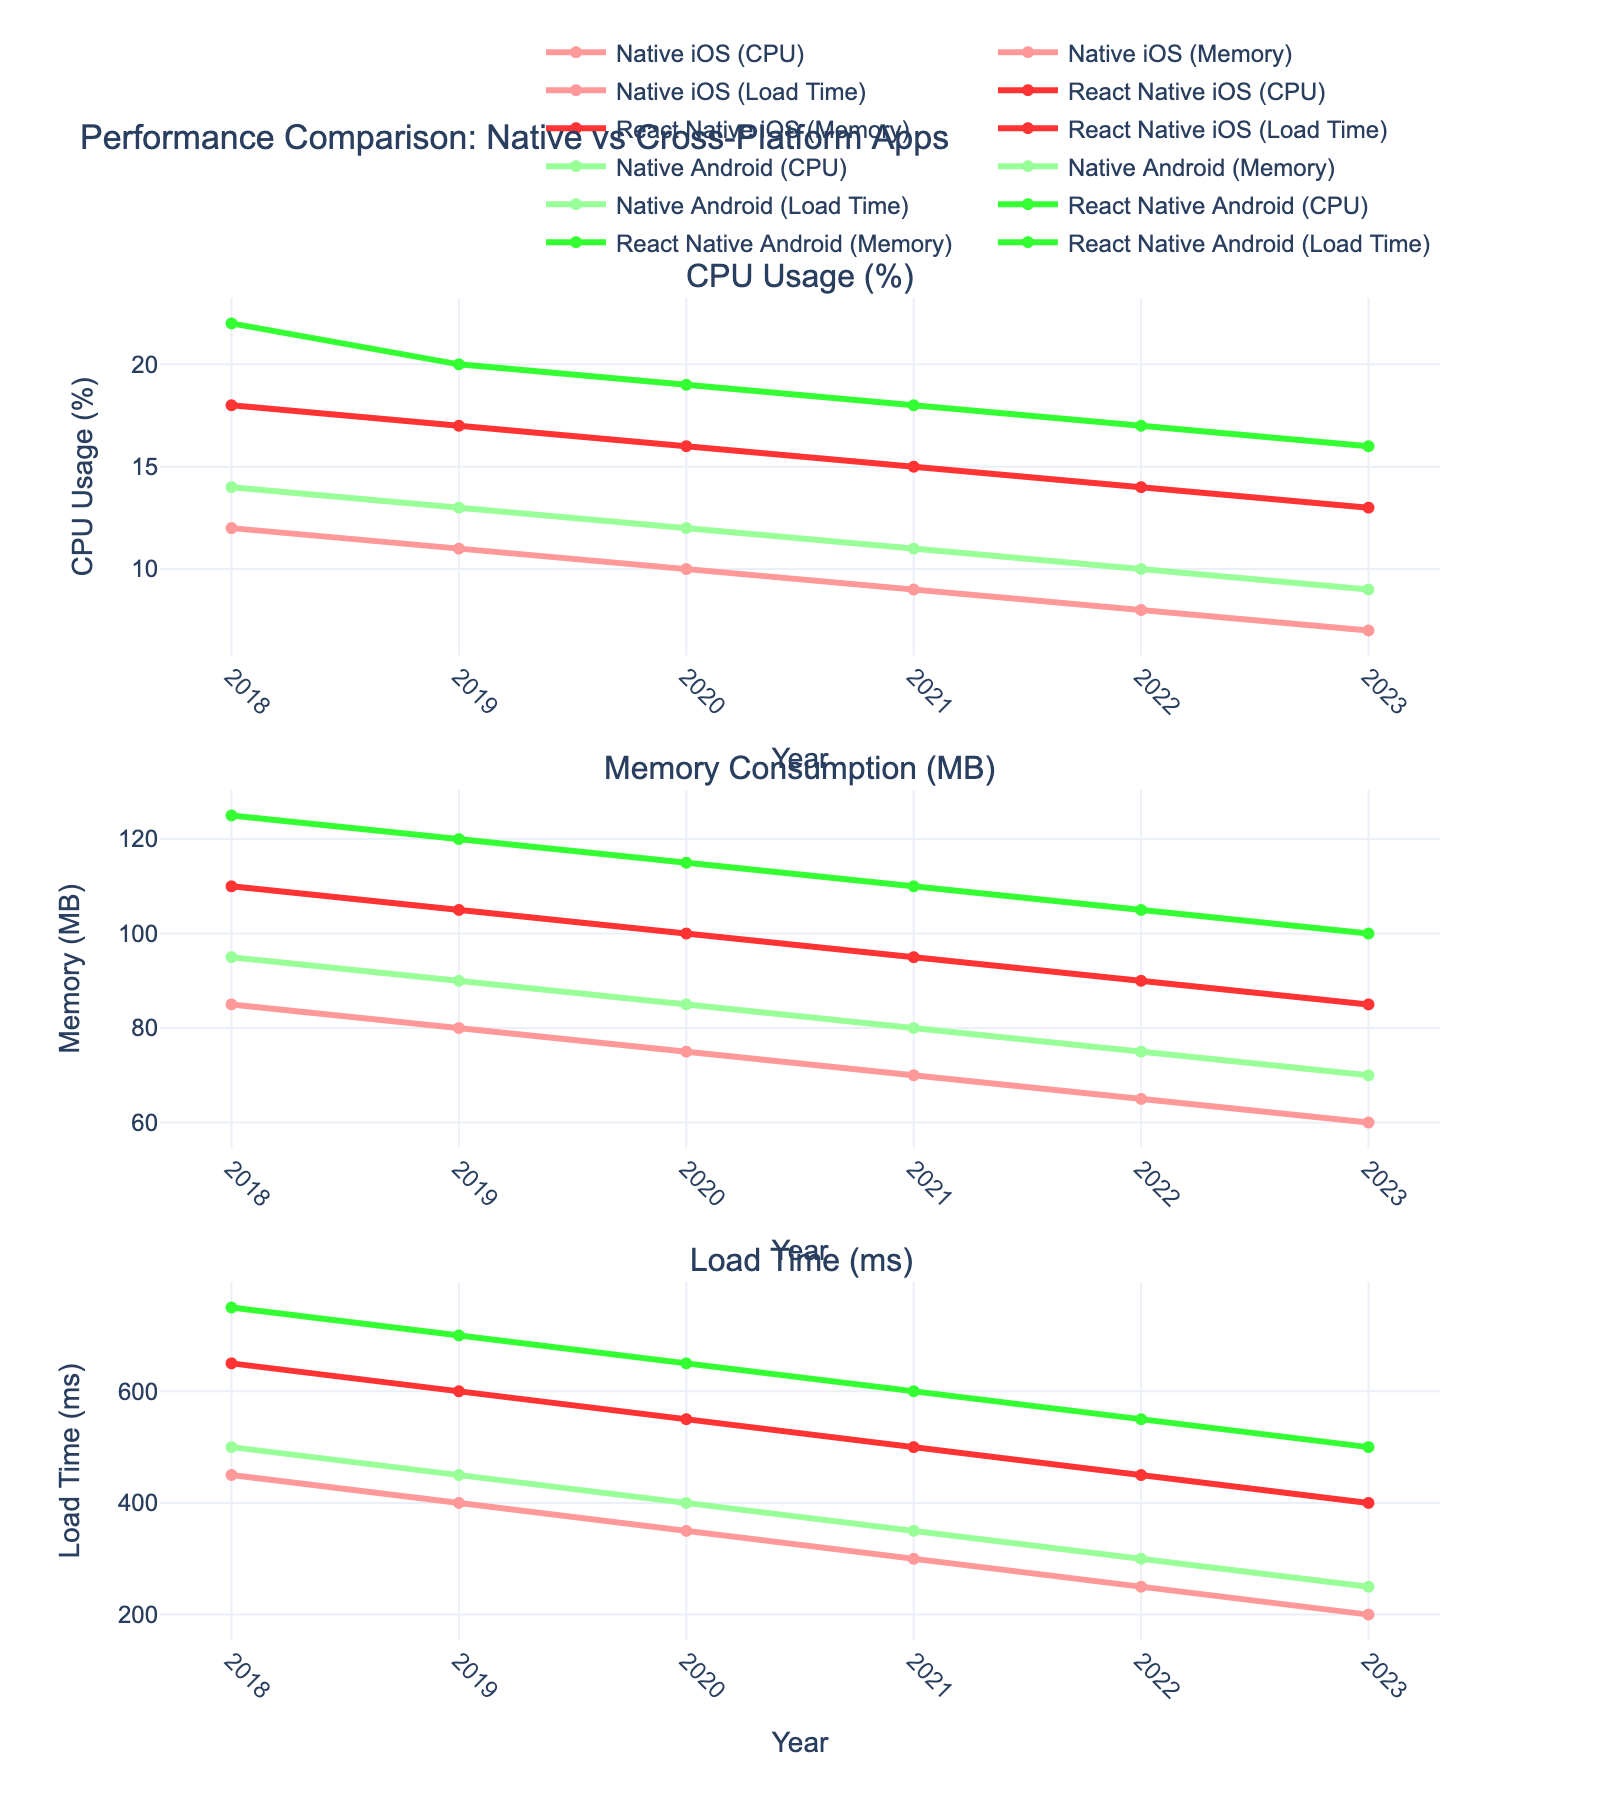Which platform has the highest CPU usage in 2023? To determine the platform with the highest CPU usage in 2023, we look at the CPU usage percentages for each platform in that year. React Native Android has the highest CPU usage at 16%.
Answer: React Native Android Which year shows the biggest difference in memory consumption between Native iOS and React Native iOS? To find the year with the biggest difference, subtract Native iOS memory from React Native iOS memory for each year and identify the maximum difference. The differences are (2018: 25 MB, 2019: 25 MB, 2020: 25 MB, 2021: 25 MB, 2022: 25 MB, 2023: 25 MB). All years have the same difference.
Answer: Any year What's the trend of load times for Native Android apps from 2018 to 2023? Observing the load time values for Native Android from 2018 to 2023: 500 ms, 450 ms, 400 ms, 350 ms, 300 ms, 250 ms, we see a consistent decreasing trend.
Answer: Decreasing What is the average memory consumption for React Native Android over the years? Sum the memory consumption of React Native Android over the years: 125 + 120 + 115 + 110 + 105 + 100 = 675 MB. Then divide by the number of years, 675 MB / 6 = 112.5 MB.
Answer: 112.5 MB How much did the CPU usage for Native iOS decrease from 2018 to 2023? The CPU usage for Native iOS in 2018 was 12%, and in 2023 it was 7%. The decrease is 12% - 7% = 5%.
Answer: 5% In which year is the load time difference between Native iOS and React Native iOS the smallest? Calculate the load time differences for each year: (2018: 200 ms, 2019: 200 ms, 2020: 200 ms, 2021: 200 ms, 2022: 200 ms, 2023: 200 ms). All years have the same difference.
Answer: Any year Which platform shows the lowest memory consumption in 2022? Look at the memory consumption values for 2022: Native iOS (65 MB), React Native iOS (90 MB), Native Android (75 MB), React Native Android (105 MB). Native iOS has the lowest memory consumption.
Answer: Native iOS How does the CPU usage of React Native iOS in 2019 compare to that in 2021? React Native iOS CPU usage in 2019 is 17%, while in 2021 it is 15%. The CPU usage has decreased by 2%.
Answer: Decreased by 2% Which platform has shown a consistent decrease in load times every year? By observing the load times from 2018 to 2023 for each platform, only Native iOS shows a consistent decrease: 450 ms, 400 ms, 350 ms, 300 ms, 250 ms, 200 ms.
Answer: Native iOS What is the ratio of React Native Android's load time to Native Android's load time in 2023? In 2023, the load time for React Native Android is 500 ms and for Native Android it is 250 ms. The ratio is 500 ms / 250 ms = 2.
Answer: 2 